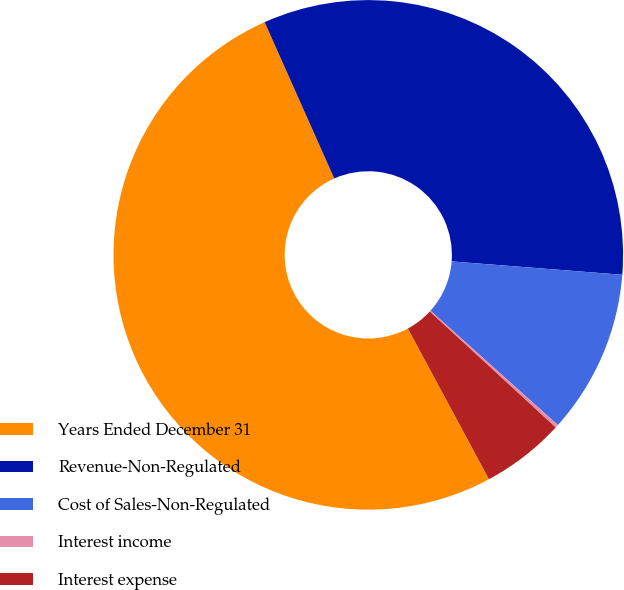<chart> <loc_0><loc_0><loc_500><loc_500><pie_chart><fcel>Years Ended December 31<fcel>Revenue-Non-Regulated<fcel>Cost of Sales-Non-Regulated<fcel>Interest income<fcel>Interest expense<nl><fcel>51.18%<fcel>32.91%<fcel>10.4%<fcel>0.2%<fcel>5.3%<nl></chart> 